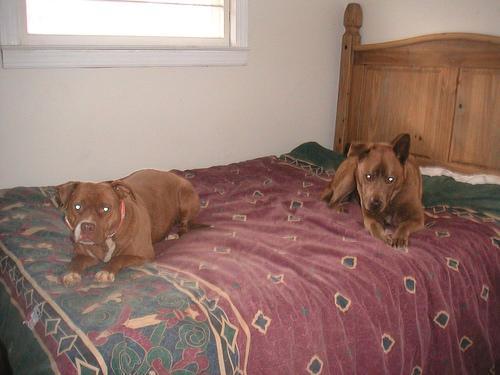How many dogs are here?
Give a very brief answer. 2. How many dogs are there?
Give a very brief answer. 2. 